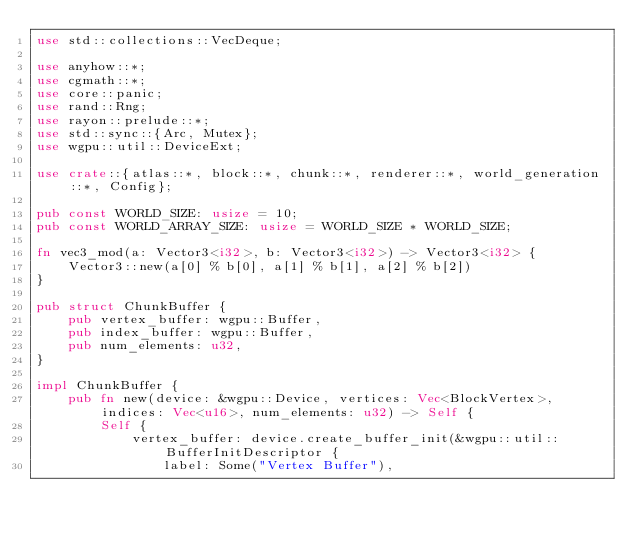<code> <loc_0><loc_0><loc_500><loc_500><_Rust_>use std::collections::VecDeque;

use anyhow::*;
use cgmath::*;
use core::panic;
use rand::Rng;
use rayon::prelude::*;
use std::sync::{Arc, Mutex};
use wgpu::util::DeviceExt;

use crate::{atlas::*, block::*, chunk::*, renderer::*, world_generation::*, Config};

pub const WORLD_SIZE: usize = 10;
pub const WORLD_ARRAY_SIZE: usize = WORLD_SIZE * WORLD_SIZE;

fn vec3_mod(a: Vector3<i32>, b: Vector3<i32>) -> Vector3<i32> {
    Vector3::new(a[0] % b[0], a[1] % b[1], a[2] % b[2])
}

pub struct ChunkBuffer {
    pub vertex_buffer: wgpu::Buffer,
    pub index_buffer: wgpu::Buffer,
    pub num_elements: u32,
}

impl ChunkBuffer {
    pub fn new(device: &wgpu::Device, vertices: Vec<BlockVertex>, indices: Vec<u16>, num_elements: u32) -> Self {
        Self {
            vertex_buffer: device.create_buffer_init(&wgpu::util::BufferInitDescriptor {
                label: Some("Vertex Buffer"),</code> 